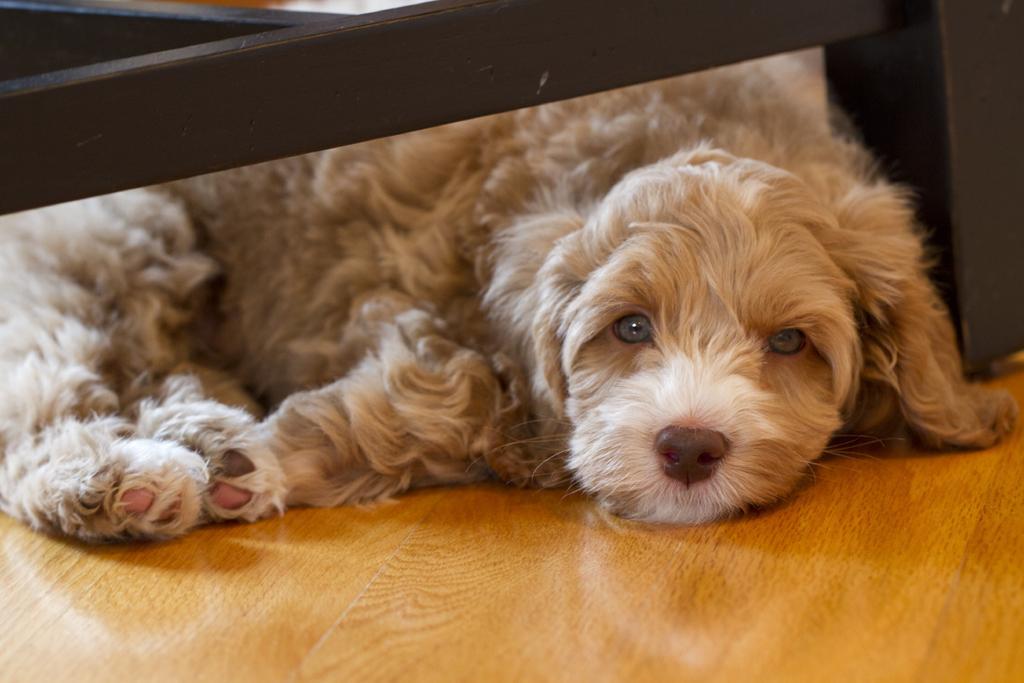In one or two sentences, can you explain what this image depicts? In this image I can see the dog which is in cream color. It is on the brown color surface. On the top I can see the black color object. 